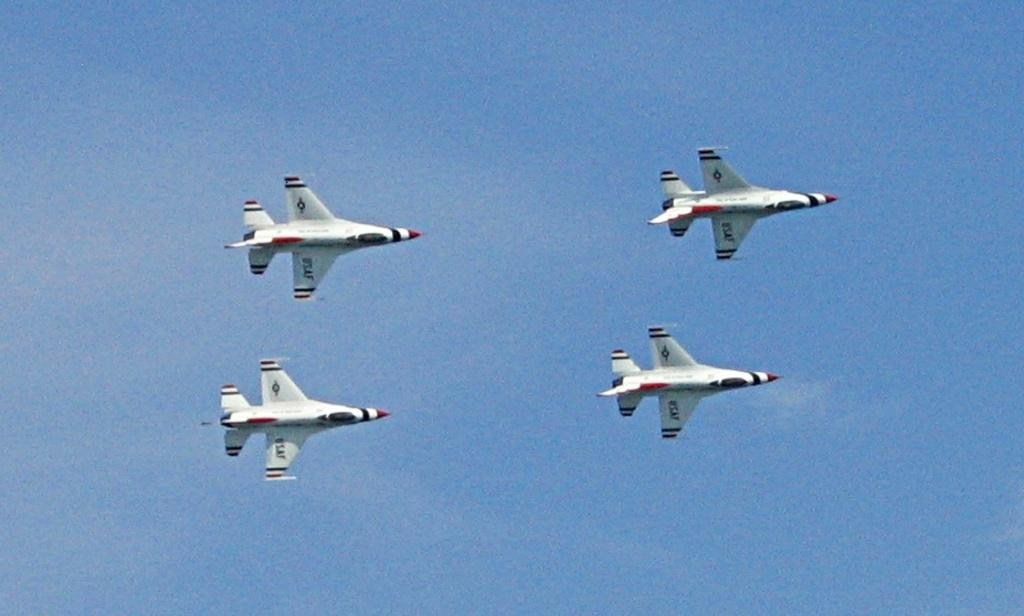How many aircrafts are visible in the image? There are four aircrafts in the image. What colors can be seen on the aircrafts? The aircrafts have different colors: white, black, and red. What is the condition of the sky in the image? The sky is clear in the image. Are there any markings or writing on the aircrafts? Yes, there is writing on the aircrafts. Can you see any wax dripping from the aircrafts in the image? There is no wax present in the image, and therefore no wax dripping can be observed. 